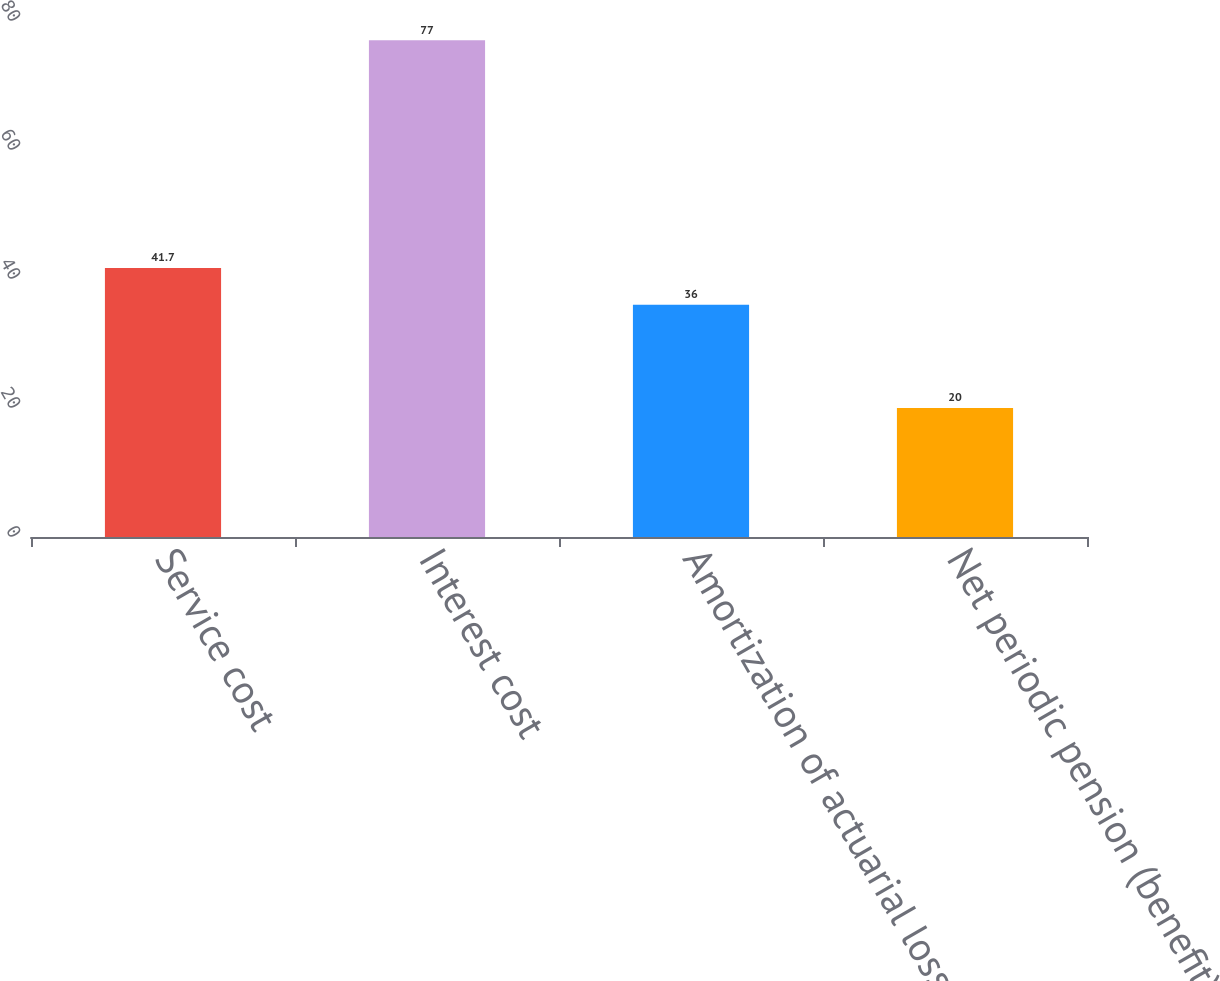<chart> <loc_0><loc_0><loc_500><loc_500><bar_chart><fcel>Service cost<fcel>Interest cost<fcel>Amortization of actuarial loss<fcel>Net periodic pension (benefit)<nl><fcel>41.7<fcel>77<fcel>36<fcel>20<nl></chart> 